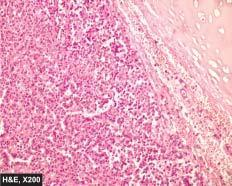re the tumour cells composed of uniform cuboidal cells having granular cytoplasm?
Answer the question using a single word or phrase. No 